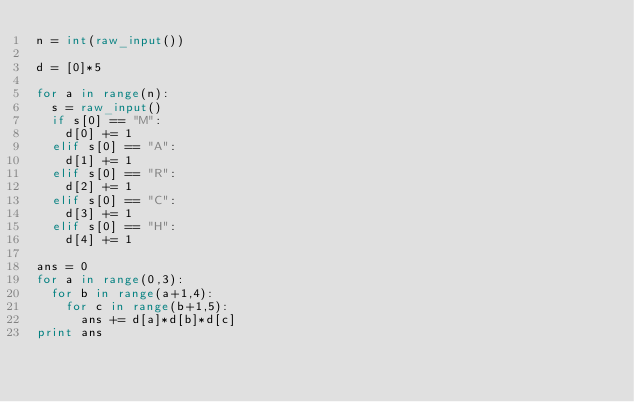<code> <loc_0><loc_0><loc_500><loc_500><_Python_>n = int(raw_input())

d = [0]*5

for a in range(n):
  s = raw_input()
  if s[0] == "M":
    d[0] += 1
  elif s[0] == "A":
    d[1] += 1
  elif s[0] == "R":
    d[2] += 1
  elif s[0] == "C":
    d[3] += 1
  elif s[0] == "H":
    d[4] += 1

ans = 0
for a in range(0,3):
  for b in range(a+1,4):
    for c in range(b+1,5):
      ans += d[a]*d[b]*d[c]
print ans
</code> 